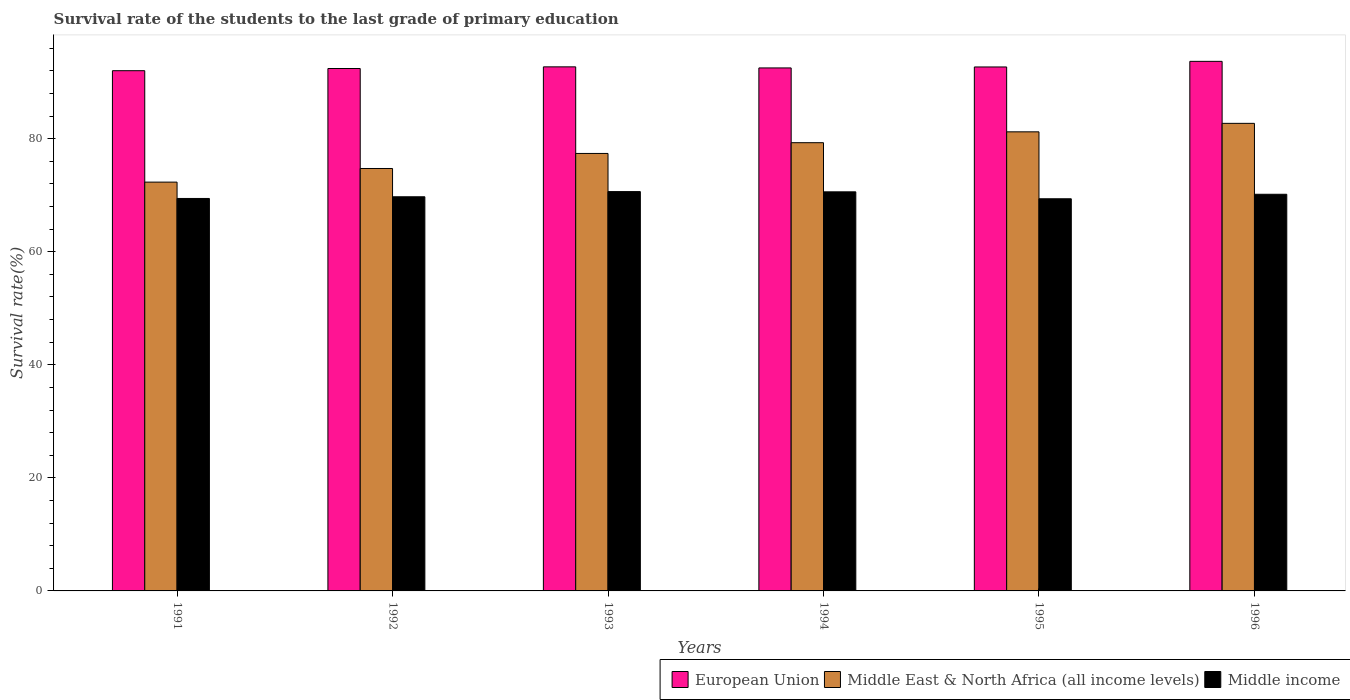How many groups of bars are there?
Your answer should be very brief. 6. Are the number of bars per tick equal to the number of legend labels?
Provide a succinct answer. Yes. What is the survival rate of the students in European Union in 1992?
Ensure brevity in your answer.  92.41. Across all years, what is the maximum survival rate of the students in Middle income?
Give a very brief answer. 70.64. Across all years, what is the minimum survival rate of the students in European Union?
Make the answer very short. 92.03. In which year was the survival rate of the students in European Union maximum?
Offer a very short reply. 1996. In which year was the survival rate of the students in Middle East & North Africa (all income levels) minimum?
Your answer should be very brief. 1991. What is the total survival rate of the students in European Union in the graph?
Give a very brief answer. 556.02. What is the difference between the survival rate of the students in Middle income in 1994 and that in 1996?
Your answer should be very brief. 0.43. What is the difference between the survival rate of the students in European Union in 1996 and the survival rate of the students in Middle East & North Africa (all income levels) in 1995?
Provide a succinct answer. 12.47. What is the average survival rate of the students in European Union per year?
Ensure brevity in your answer.  92.67. In the year 1991, what is the difference between the survival rate of the students in Middle East & North Africa (all income levels) and survival rate of the students in European Union?
Provide a succinct answer. -19.71. What is the ratio of the survival rate of the students in European Union in 1994 to that in 1996?
Provide a short and direct response. 0.99. What is the difference between the highest and the second highest survival rate of the students in Middle income?
Your answer should be very brief. 0.04. What is the difference between the highest and the lowest survival rate of the students in Middle East & North Africa (all income levels)?
Make the answer very short. 10.4. In how many years, is the survival rate of the students in European Union greater than the average survival rate of the students in European Union taken over all years?
Make the answer very short. 3. Is the sum of the survival rate of the students in European Union in 1991 and 1992 greater than the maximum survival rate of the students in Middle income across all years?
Give a very brief answer. Yes. What does the 2nd bar from the left in 1993 represents?
Ensure brevity in your answer.  Middle East & North Africa (all income levels). What does the 2nd bar from the right in 1995 represents?
Provide a succinct answer. Middle East & North Africa (all income levels). Are all the bars in the graph horizontal?
Your answer should be compact. No. How many years are there in the graph?
Give a very brief answer. 6. What is the difference between two consecutive major ticks on the Y-axis?
Offer a terse response. 20. Does the graph contain grids?
Offer a terse response. No. Where does the legend appear in the graph?
Keep it short and to the point. Bottom right. How many legend labels are there?
Ensure brevity in your answer.  3. How are the legend labels stacked?
Make the answer very short. Horizontal. What is the title of the graph?
Your answer should be very brief. Survival rate of the students to the last grade of primary education. What is the label or title of the Y-axis?
Give a very brief answer. Survival rate(%). What is the Survival rate(%) in European Union in 1991?
Make the answer very short. 92.03. What is the Survival rate(%) of Middle East & North Africa (all income levels) in 1991?
Provide a short and direct response. 72.32. What is the Survival rate(%) of Middle income in 1991?
Keep it short and to the point. 69.42. What is the Survival rate(%) in European Union in 1992?
Your answer should be compact. 92.41. What is the Survival rate(%) in Middle East & North Africa (all income levels) in 1992?
Give a very brief answer. 74.73. What is the Survival rate(%) of Middle income in 1992?
Ensure brevity in your answer.  69.72. What is the Survival rate(%) in European Union in 1993?
Keep it short and to the point. 92.71. What is the Survival rate(%) in Middle East & North Africa (all income levels) in 1993?
Offer a terse response. 77.39. What is the Survival rate(%) in Middle income in 1993?
Ensure brevity in your answer.  70.64. What is the Survival rate(%) in European Union in 1994?
Offer a terse response. 92.51. What is the Survival rate(%) in Middle East & North Africa (all income levels) in 1994?
Your answer should be compact. 79.29. What is the Survival rate(%) of Middle income in 1994?
Offer a very short reply. 70.6. What is the Survival rate(%) in European Union in 1995?
Your answer should be compact. 92.69. What is the Survival rate(%) of Middle East & North Africa (all income levels) in 1995?
Offer a terse response. 81.21. What is the Survival rate(%) in Middle income in 1995?
Provide a succinct answer. 69.37. What is the Survival rate(%) of European Union in 1996?
Ensure brevity in your answer.  93.68. What is the Survival rate(%) in Middle East & North Africa (all income levels) in 1996?
Ensure brevity in your answer.  82.71. What is the Survival rate(%) in Middle income in 1996?
Keep it short and to the point. 70.16. Across all years, what is the maximum Survival rate(%) of European Union?
Keep it short and to the point. 93.68. Across all years, what is the maximum Survival rate(%) of Middle East & North Africa (all income levels)?
Your response must be concise. 82.71. Across all years, what is the maximum Survival rate(%) of Middle income?
Make the answer very short. 70.64. Across all years, what is the minimum Survival rate(%) in European Union?
Your answer should be compact. 92.03. Across all years, what is the minimum Survival rate(%) in Middle East & North Africa (all income levels)?
Offer a terse response. 72.32. Across all years, what is the minimum Survival rate(%) of Middle income?
Keep it short and to the point. 69.37. What is the total Survival rate(%) in European Union in the graph?
Offer a terse response. 556.02. What is the total Survival rate(%) in Middle East & North Africa (all income levels) in the graph?
Provide a short and direct response. 467.64. What is the total Survival rate(%) of Middle income in the graph?
Your response must be concise. 419.91. What is the difference between the Survival rate(%) of European Union in 1991 and that in 1992?
Your answer should be compact. -0.39. What is the difference between the Survival rate(%) in Middle East & North Africa (all income levels) in 1991 and that in 1992?
Provide a short and direct response. -2.41. What is the difference between the Survival rate(%) in Middle income in 1991 and that in 1992?
Give a very brief answer. -0.3. What is the difference between the Survival rate(%) of European Union in 1991 and that in 1993?
Ensure brevity in your answer.  -0.68. What is the difference between the Survival rate(%) in Middle East & North Africa (all income levels) in 1991 and that in 1993?
Your response must be concise. -5.07. What is the difference between the Survival rate(%) of Middle income in 1991 and that in 1993?
Offer a very short reply. -1.21. What is the difference between the Survival rate(%) of European Union in 1991 and that in 1994?
Offer a very short reply. -0.49. What is the difference between the Survival rate(%) of Middle East & North Africa (all income levels) in 1991 and that in 1994?
Your answer should be very brief. -6.97. What is the difference between the Survival rate(%) in Middle income in 1991 and that in 1994?
Make the answer very short. -1.17. What is the difference between the Survival rate(%) in European Union in 1991 and that in 1995?
Provide a succinct answer. -0.66. What is the difference between the Survival rate(%) in Middle East & North Africa (all income levels) in 1991 and that in 1995?
Offer a terse response. -8.89. What is the difference between the Survival rate(%) in Middle income in 1991 and that in 1995?
Offer a terse response. 0.05. What is the difference between the Survival rate(%) in European Union in 1991 and that in 1996?
Offer a very short reply. -1.65. What is the difference between the Survival rate(%) in Middle East & North Africa (all income levels) in 1991 and that in 1996?
Your answer should be compact. -10.4. What is the difference between the Survival rate(%) in Middle income in 1991 and that in 1996?
Provide a succinct answer. -0.74. What is the difference between the Survival rate(%) in European Union in 1992 and that in 1993?
Ensure brevity in your answer.  -0.29. What is the difference between the Survival rate(%) of Middle East & North Africa (all income levels) in 1992 and that in 1993?
Your answer should be compact. -2.66. What is the difference between the Survival rate(%) in Middle income in 1992 and that in 1993?
Your answer should be compact. -0.92. What is the difference between the Survival rate(%) of European Union in 1992 and that in 1994?
Provide a succinct answer. -0.1. What is the difference between the Survival rate(%) of Middle East & North Africa (all income levels) in 1992 and that in 1994?
Provide a succinct answer. -4.56. What is the difference between the Survival rate(%) of Middle income in 1992 and that in 1994?
Provide a succinct answer. -0.87. What is the difference between the Survival rate(%) of European Union in 1992 and that in 1995?
Your response must be concise. -0.27. What is the difference between the Survival rate(%) in Middle East & North Africa (all income levels) in 1992 and that in 1995?
Offer a terse response. -6.48. What is the difference between the Survival rate(%) in Middle income in 1992 and that in 1995?
Your answer should be compact. 0.35. What is the difference between the Survival rate(%) of European Union in 1992 and that in 1996?
Offer a terse response. -1.26. What is the difference between the Survival rate(%) in Middle East & North Africa (all income levels) in 1992 and that in 1996?
Offer a terse response. -7.99. What is the difference between the Survival rate(%) in Middle income in 1992 and that in 1996?
Provide a succinct answer. -0.44. What is the difference between the Survival rate(%) of European Union in 1993 and that in 1994?
Offer a very short reply. 0.19. What is the difference between the Survival rate(%) of Middle East & North Africa (all income levels) in 1993 and that in 1994?
Offer a terse response. -1.9. What is the difference between the Survival rate(%) of Middle income in 1993 and that in 1994?
Offer a terse response. 0.04. What is the difference between the Survival rate(%) in European Union in 1993 and that in 1995?
Make the answer very short. 0.02. What is the difference between the Survival rate(%) in Middle East & North Africa (all income levels) in 1993 and that in 1995?
Your answer should be very brief. -3.82. What is the difference between the Survival rate(%) in Middle income in 1993 and that in 1995?
Your answer should be compact. 1.27. What is the difference between the Survival rate(%) in European Union in 1993 and that in 1996?
Ensure brevity in your answer.  -0.97. What is the difference between the Survival rate(%) in Middle East & North Africa (all income levels) in 1993 and that in 1996?
Make the answer very short. -5.32. What is the difference between the Survival rate(%) of Middle income in 1993 and that in 1996?
Ensure brevity in your answer.  0.47. What is the difference between the Survival rate(%) of European Union in 1994 and that in 1995?
Offer a very short reply. -0.17. What is the difference between the Survival rate(%) of Middle East & North Africa (all income levels) in 1994 and that in 1995?
Offer a terse response. -1.92. What is the difference between the Survival rate(%) in Middle income in 1994 and that in 1995?
Your response must be concise. 1.23. What is the difference between the Survival rate(%) in European Union in 1994 and that in 1996?
Your answer should be compact. -1.16. What is the difference between the Survival rate(%) in Middle East & North Africa (all income levels) in 1994 and that in 1996?
Give a very brief answer. -3.42. What is the difference between the Survival rate(%) in Middle income in 1994 and that in 1996?
Provide a short and direct response. 0.43. What is the difference between the Survival rate(%) of European Union in 1995 and that in 1996?
Provide a succinct answer. -0.99. What is the difference between the Survival rate(%) in Middle East & North Africa (all income levels) in 1995 and that in 1996?
Offer a very short reply. -1.5. What is the difference between the Survival rate(%) in Middle income in 1995 and that in 1996?
Offer a terse response. -0.8. What is the difference between the Survival rate(%) in European Union in 1991 and the Survival rate(%) in Middle East & North Africa (all income levels) in 1992?
Ensure brevity in your answer.  17.3. What is the difference between the Survival rate(%) in European Union in 1991 and the Survival rate(%) in Middle income in 1992?
Your response must be concise. 22.3. What is the difference between the Survival rate(%) in Middle East & North Africa (all income levels) in 1991 and the Survival rate(%) in Middle income in 1992?
Give a very brief answer. 2.59. What is the difference between the Survival rate(%) of European Union in 1991 and the Survival rate(%) of Middle East & North Africa (all income levels) in 1993?
Offer a very short reply. 14.64. What is the difference between the Survival rate(%) of European Union in 1991 and the Survival rate(%) of Middle income in 1993?
Offer a terse response. 21.39. What is the difference between the Survival rate(%) in Middle East & North Africa (all income levels) in 1991 and the Survival rate(%) in Middle income in 1993?
Give a very brief answer. 1.68. What is the difference between the Survival rate(%) of European Union in 1991 and the Survival rate(%) of Middle East & North Africa (all income levels) in 1994?
Give a very brief answer. 12.74. What is the difference between the Survival rate(%) of European Union in 1991 and the Survival rate(%) of Middle income in 1994?
Ensure brevity in your answer.  21.43. What is the difference between the Survival rate(%) of Middle East & North Africa (all income levels) in 1991 and the Survival rate(%) of Middle income in 1994?
Offer a terse response. 1.72. What is the difference between the Survival rate(%) in European Union in 1991 and the Survival rate(%) in Middle East & North Africa (all income levels) in 1995?
Keep it short and to the point. 10.82. What is the difference between the Survival rate(%) in European Union in 1991 and the Survival rate(%) in Middle income in 1995?
Offer a terse response. 22.66. What is the difference between the Survival rate(%) of Middle East & North Africa (all income levels) in 1991 and the Survival rate(%) of Middle income in 1995?
Your response must be concise. 2.95. What is the difference between the Survival rate(%) of European Union in 1991 and the Survival rate(%) of Middle East & North Africa (all income levels) in 1996?
Offer a very short reply. 9.31. What is the difference between the Survival rate(%) in European Union in 1991 and the Survival rate(%) in Middle income in 1996?
Make the answer very short. 21.86. What is the difference between the Survival rate(%) in Middle East & North Africa (all income levels) in 1991 and the Survival rate(%) in Middle income in 1996?
Ensure brevity in your answer.  2.15. What is the difference between the Survival rate(%) of European Union in 1992 and the Survival rate(%) of Middle East & North Africa (all income levels) in 1993?
Ensure brevity in your answer.  15.02. What is the difference between the Survival rate(%) in European Union in 1992 and the Survival rate(%) in Middle income in 1993?
Offer a terse response. 21.77. What is the difference between the Survival rate(%) in Middle East & North Africa (all income levels) in 1992 and the Survival rate(%) in Middle income in 1993?
Offer a very short reply. 4.09. What is the difference between the Survival rate(%) of European Union in 1992 and the Survival rate(%) of Middle East & North Africa (all income levels) in 1994?
Offer a terse response. 13.12. What is the difference between the Survival rate(%) of European Union in 1992 and the Survival rate(%) of Middle income in 1994?
Provide a succinct answer. 21.82. What is the difference between the Survival rate(%) of Middle East & North Africa (all income levels) in 1992 and the Survival rate(%) of Middle income in 1994?
Your answer should be compact. 4.13. What is the difference between the Survival rate(%) of European Union in 1992 and the Survival rate(%) of Middle East & North Africa (all income levels) in 1995?
Give a very brief answer. 11.2. What is the difference between the Survival rate(%) of European Union in 1992 and the Survival rate(%) of Middle income in 1995?
Your answer should be compact. 23.04. What is the difference between the Survival rate(%) of Middle East & North Africa (all income levels) in 1992 and the Survival rate(%) of Middle income in 1995?
Offer a terse response. 5.36. What is the difference between the Survival rate(%) in European Union in 1992 and the Survival rate(%) in Middle East & North Africa (all income levels) in 1996?
Your answer should be very brief. 9.7. What is the difference between the Survival rate(%) of European Union in 1992 and the Survival rate(%) of Middle income in 1996?
Your answer should be very brief. 22.25. What is the difference between the Survival rate(%) of Middle East & North Africa (all income levels) in 1992 and the Survival rate(%) of Middle income in 1996?
Your response must be concise. 4.56. What is the difference between the Survival rate(%) of European Union in 1993 and the Survival rate(%) of Middle East & North Africa (all income levels) in 1994?
Give a very brief answer. 13.42. What is the difference between the Survival rate(%) in European Union in 1993 and the Survival rate(%) in Middle income in 1994?
Keep it short and to the point. 22.11. What is the difference between the Survival rate(%) in Middle East & North Africa (all income levels) in 1993 and the Survival rate(%) in Middle income in 1994?
Your answer should be very brief. 6.79. What is the difference between the Survival rate(%) in European Union in 1993 and the Survival rate(%) in Middle East & North Africa (all income levels) in 1995?
Keep it short and to the point. 11.5. What is the difference between the Survival rate(%) of European Union in 1993 and the Survival rate(%) of Middle income in 1995?
Give a very brief answer. 23.34. What is the difference between the Survival rate(%) of Middle East & North Africa (all income levels) in 1993 and the Survival rate(%) of Middle income in 1995?
Your answer should be very brief. 8.02. What is the difference between the Survival rate(%) in European Union in 1993 and the Survival rate(%) in Middle East & North Africa (all income levels) in 1996?
Your response must be concise. 10. What is the difference between the Survival rate(%) of European Union in 1993 and the Survival rate(%) of Middle income in 1996?
Ensure brevity in your answer.  22.54. What is the difference between the Survival rate(%) in Middle East & North Africa (all income levels) in 1993 and the Survival rate(%) in Middle income in 1996?
Make the answer very short. 7.22. What is the difference between the Survival rate(%) of European Union in 1994 and the Survival rate(%) of Middle East & North Africa (all income levels) in 1995?
Ensure brevity in your answer.  11.31. What is the difference between the Survival rate(%) in European Union in 1994 and the Survival rate(%) in Middle income in 1995?
Keep it short and to the point. 23.15. What is the difference between the Survival rate(%) of Middle East & North Africa (all income levels) in 1994 and the Survival rate(%) of Middle income in 1995?
Your response must be concise. 9.92. What is the difference between the Survival rate(%) of European Union in 1994 and the Survival rate(%) of Middle East & North Africa (all income levels) in 1996?
Your answer should be compact. 9.8. What is the difference between the Survival rate(%) of European Union in 1994 and the Survival rate(%) of Middle income in 1996?
Ensure brevity in your answer.  22.35. What is the difference between the Survival rate(%) of Middle East & North Africa (all income levels) in 1994 and the Survival rate(%) of Middle income in 1996?
Keep it short and to the point. 9.12. What is the difference between the Survival rate(%) of European Union in 1995 and the Survival rate(%) of Middle East & North Africa (all income levels) in 1996?
Provide a short and direct response. 9.97. What is the difference between the Survival rate(%) of European Union in 1995 and the Survival rate(%) of Middle income in 1996?
Your answer should be very brief. 22.52. What is the difference between the Survival rate(%) of Middle East & North Africa (all income levels) in 1995 and the Survival rate(%) of Middle income in 1996?
Provide a succinct answer. 11.05. What is the average Survival rate(%) in European Union per year?
Offer a terse response. 92.67. What is the average Survival rate(%) of Middle East & North Africa (all income levels) per year?
Ensure brevity in your answer.  77.94. What is the average Survival rate(%) in Middle income per year?
Make the answer very short. 69.99. In the year 1991, what is the difference between the Survival rate(%) in European Union and Survival rate(%) in Middle East & North Africa (all income levels)?
Offer a terse response. 19.71. In the year 1991, what is the difference between the Survival rate(%) of European Union and Survival rate(%) of Middle income?
Keep it short and to the point. 22.6. In the year 1991, what is the difference between the Survival rate(%) of Middle East & North Africa (all income levels) and Survival rate(%) of Middle income?
Ensure brevity in your answer.  2.89. In the year 1992, what is the difference between the Survival rate(%) in European Union and Survival rate(%) in Middle East & North Africa (all income levels)?
Your answer should be very brief. 17.69. In the year 1992, what is the difference between the Survival rate(%) in European Union and Survival rate(%) in Middle income?
Make the answer very short. 22.69. In the year 1992, what is the difference between the Survival rate(%) of Middle East & North Africa (all income levels) and Survival rate(%) of Middle income?
Your response must be concise. 5. In the year 1993, what is the difference between the Survival rate(%) in European Union and Survival rate(%) in Middle East & North Africa (all income levels)?
Your response must be concise. 15.32. In the year 1993, what is the difference between the Survival rate(%) of European Union and Survival rate(%) of Middle income?
Provide a succinct answer. 22.07. In the year 1993, what is the difference between the Survival rate(%) in Middle East & North Africa (all income levels) and Survival rate(%) in Middle income?
Provide a succinct answer. 6.75. In the year 1994, what is the difference between the Survival rate(%) in European Union and Survival rate(%) in Middle East & North Africa (all income levels)?
Offer a terse response. 13.23. In the year 1994, what is the difference between the Survival rate(%) in European Union and Survival rate(%) in Middle income?
Your answer should be very brief. 21.92. In the year 1994, what is the difference between the Survival rate(%) of Middle East & North Africa (all income levels) and Survival rate(%) of Middle income?
Provide a short and direct response. 8.69. In the year 1995, what is the difference between the Survival rate(%) of European Union and Survival rate(%) of Middle East & North Africa (all income levels)?
Keep it short and to the point. 11.48. In the year 1995, what is the difference between the Survival rate(%) in European Union and Survival rate(%) in Middle income?
Offer a very short reply. 23.32. In the year 1995, what is the difference between the Survival rate(%) in Middle East & North Africa (all income levels) and Survival rate(%) in Middle income?
Offer a very short reply. 11.84. In the year 1996, what is the difference between the Survival rate(%) in European Union and Survival rate(%) in Middle East & North Africa (all income levels)?
Ensure brevity in your answer.  10.97. In the year 1996, what is the difference between the Survival rate(%) of European Union and Survival rate(%) of Middle income?
Your answer should be very brief. 23.51. In the year 1996, what is the difference between the Survival rate(%) of Middle East & North Africa (all income levels) and Survival rate(%) of Middle income?
Ensure brevity in your answer.  12.55. What is the ratio of the Survival rate(%) of European Union in 1991 to that in 1992?
Your answer should be very brief. 1. What is the ratio of the Survival rate(%) in Middle East & North Africa (all income levels) in 1991 to that in 1992?
Provide a short and direct response. 0.97. What is the ratio of the Survival rate(%) in Middle East & North Africa (all income levels) in 1991 to that in 1993?
Offer a terse response. 0.93. What is the ratio of the Survival rate(%) of Middle income in 1991 to that in 1993?
Offer a terse response. 0.98. What is the ratio of the Survival rate(%) of Middle East & North Africa (all income levels) in 1991 to that in 1994?
Your response must be concise. 0.91. What is the ratio of the Survival rate(%) in Middle income in 1991 to that in 1994?
Give a very brief answer. 0.98. What is the ratio of the Survival rate(%) in Middle East & North Africa (all income levels) in 1991 to that in 1995?
Your answer should be very brief. 0.89. What is the ratio of the Survival rate(%) of Middle income in 1991 to that in 1995?
Offer a very short reply. 1. What is the ratio of the Survival rate(%) of European Union in 1991 to that in 1996?
Make the answer very short. 0.98. What is the ratio of the Survival rate(%) in Middle East & North Africa (all income levels) in 1991 to that in 1996?
Your answer should be very brief. 0.87. What is the ratio of the Survival rate(%) in Middle East & North Africa (all income levels) in 1992 to that in 1993?
Provide a short and direct response. 0.97. What is the ratio of the Survival rate(%) of European Union in 1992 to that in 1994?
Give a very brief answer. 1. What is the ratio of the Survival rate(%) in Middle East & North Africa (all income levels) in 1992 to that in 1994?
Your response must be concise. 0.94. What is the ratio of the Survival rate(%) in Middle income in 1992 to that in 1994?
Give a very brief answer. 0.99. What is the ratio of the Survival rate(%) in Middle East & North Africa (all income levels) in 1992 to that in 1995?
Give a very brief answer. 0.92. What is the ratio of the Survival rate(%) in European Union in 1992 to that in 1996?
Provide a short and direct response. 0.99. What is the ratio of the Survival rate(%) in Middle East & North Africa (all income levels) in 1992 to that in 1996?
Your response must be concise. 0.9. What is the ratio of the Survival rate(%) in Middle income in 1992 to that in 1996?
Keep it short and to the point. 0.99. What is the ratio of the Survival rate(%) in European Union in 1993 to that in 1994?
Offer a very short reply. 1. What is the ratio of the Survival rate(%) in Middle income in 1993 to that in 1994?
Offer a very short reply. 1. What is the ratio of the Survival rate(%) in Middle East & North Africa (all income levels) in 1993 to that in 1995?
Give a very brief answer. 0.95. What is the ratio of the Survival rate(%) in Middle income in 1993 to that in 1995?
Your response must be concise. 1.02. What is the ratio of the Survival rate(%) of Middle East & North Africa (all income levels) in 1993 to that in 1996?
Make the answer very short. 0.94. What is the ratio of the Survival rate(%) in Middle income in 1993 to that in 1996?
Provide a short and direct response. 1.01. What is the ratio of the Survival rate(%) in Middle East & North Africa (all income levels) in 1994 to that in 1995?
Your answer should be compact. 0.98. What is the ratio of the Survival rate(%) in Middle income in 1994 to that in 1995?
Ensure brevity in your answer.  1.02. What is the ratio of the Survival rate(%) of European Union in 1994 to that in 1996?
Keep it short and to the point. 0.99. What is the ratio of the Survival rate(%) of Middle East & North Africa (all income levels) in 1994 to that in 1996?
Give a very brief answer. 0.96. What is the ratio of the Survival rate(%) of Middle East & North Africa (all income levels) in 1995 to that in 1996?
Give a very brief answer. 0.98. What is the ratio of the Survival rate(%) of Middle income in 1995 to that in 1996?
Keep it short and to the point. 0.99. What is the difference between the highest and the second highest Survival rate(%) in European Union?
Your answer should be very brief. 0.97. What is the difference between the highest and the second highest Survival rate(%) in Middle East & North Africa (all income levels)?
Keep it short and to the point. 1.5. What is the difference between the highest and the second highest Survival rate(%) in Middle income?
Make the answer very short. 0.04. What is the difference between the highest and the lowest Survival rate(%) in European Union?
Make the answer very short. 1.65. What is the difference between the highest and the lowest Survival rate(%) of Middle East & North Africa (all income levels)?
Your answer should be very brief. 10.4. What is the difference between the highest and the lowest Survival rate(%) of Middle income?
Your response must be concise. 1.27. 